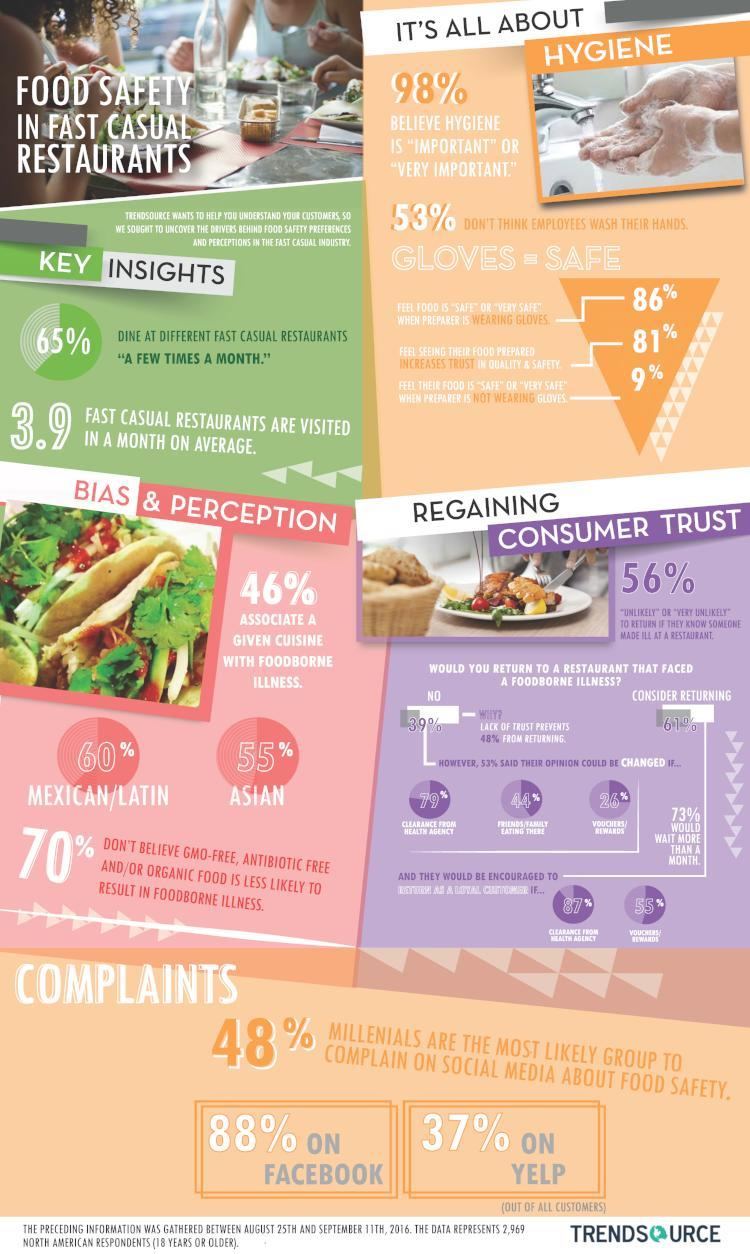How many of the people associate Asian food with foodborne illness?
Answer the question with a short phrase. 55% How many of the people are unlikely to return if they know of any case of foodborne illness 56% What percent of customers believe hygiene is very important? 98% How many of the people associate Mexican food with foodborne illness? 60% 